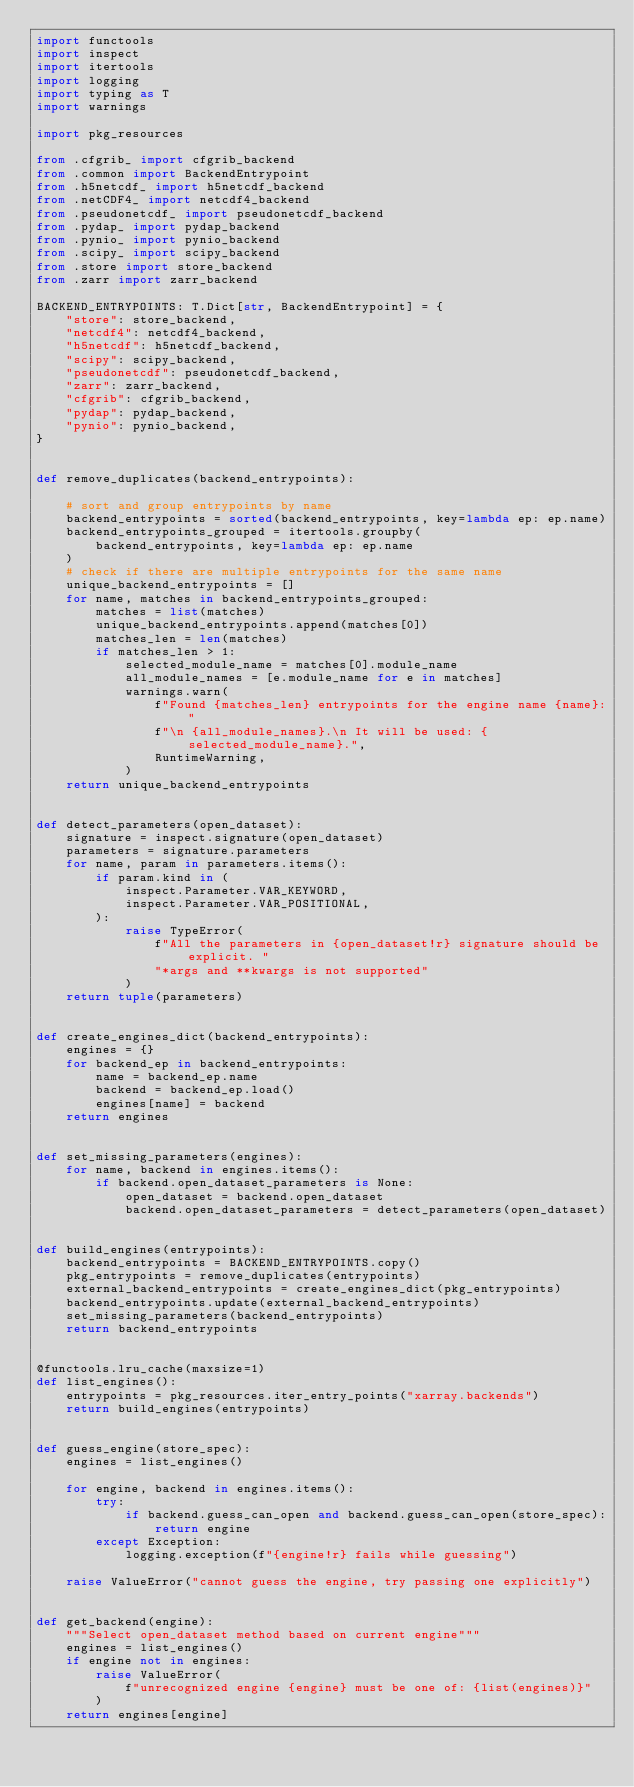Convert code to text. <code><loc_0><loc_0><loc_500><loc_500><_Python_>import functools
import inspect
import itertools
import logging
import typing as T
import warnings

import pkg_resources

from .cfgrib_ import cfgrib_backend
from .common import BackendEntrypoint
from .h5netcdf_ import h5netcdf_backend
from .netCDF4_ import netcdf4_backend
from .pseudonetcdf_ import pseudonetcdf_backend
from .pydap_ import pydap_backend
from .pynio_ import pynio_backend
from .scipy_ import scipy_backend
from .store import store_backend
from .zarr import zarr_backend

BACKEND_ENTRYPOINTS: T.Dict[str, BackendEntrypoint] = {
    "store": store_backend,
    "netcdf4": netcdf4_backend,
    "h5netcdf": h5netcdf_backend,
    "scipy": scipy_backend,
    "pseudonetcdf": pseudonetcdf_backend,
    "zarr": zarr_backend,
    "cfgrib": cfgrib_backend,
    "pydap": pydap_backend,
    "pynio": pynio_backend,
}


def remove_duplicates(backend_entrypoints):

    # sort and group entrypoints by name
    backend_entrypoints = sorted(backend_entrypoints, key=lambda ep: ep.name)
    backend_entrypoints_grouped = itertools.groupby(
        backend_entrypoints, key=lambda ep: ep.name
    )
    # check if there are multiple entrypoints for the same name
    unique_backend_entrypoints = []
    for name, matches in backend_entrypoints_grouped:
        matches = list(matches)
        unique_backend_entrypoints.append(matches[0])
        matches_len = len(matches)
        if matches_len > 1:
            selected_module_name = matches[0].module_name
            all_module_names = [e.module_name for e in matches]
            warnings.warn(
                f"Found {matches_len} entrypoints for the engine name {name}:"
                f"\n {all_module_names}.\n It will be used: {selected_module_name}.",
                RuntimeWarning,
            )
    return unique_backend_entrypoints


def detect_parameters(open_dataset):
    signature = inspect.signature(open_dataset)
    parameters = signature.parameters
    for name, param in parameters.items():
        if param.kind in (
            inspect.Parameter.VAR_KEYWORD,
            inspect.Parameter.VAR_POSITIONAL,
        ):
            raise TypeError(
                f"All the parameters in {open_dataset!r} signature should be explicit. "
                "*args and **kwargs is not supported"
            )
    return tuple(parameters)


def create_engines_dict(backend_entrypoints):
    engines = {}
    for backend_ep in backend_entrypoints:
        name = backend_ep.name
        backend = backend_ep.load()
        engines[name] = backend
    return engines


def set_missing_parameters(engines):
    for name, backend in engines.items():
        if backend.open_dataset_parameters is None:
            open_dataset = backend.open_dataset
            backend.open_dataset_parameters = detect_parameters(open_dataset)


def build_engines(entrypoints):
    backend_entrypoints = BACKEND_ENTRYPOINTS.copy()
    pkg_entrypoints = remove_duplicates(entrypoints)
    external_backend_entrypoints = create_engines_dict(pkg_entrypoints)
    backend_entrypoints.update(external_backend_entrypoints)
    set_missing_parameters(backend_entrypoints)
    return backend_entrypoints


@functools.lru_cache(maxsize=1)
def list_engines():
    entrypoints = pkg_resources.iter_entry_points("xarray.backends")
    return build_engines(entrypoints)


def guess_engine(store_spec):
    engines = list_engines()

    for engine, backend in engines.items():
        try:
            if backend.guess_can_open and backend.guess_can_open(store_spec):
                return engine
        except Exception:
            logging.exception(f"{engine!r} fails while guessing")

    raise ValueError("cannot guess the engine, try passing one explicitly")


def get_backend(engine):
    """Select open_dataset method based on current engine"""
    engines = list_engines()
    if engine not in engines:
        raise ValueError(
            f"unrecognized engine {engine} must be one of: {list(engines)}"
        )
    return engines[engine]
</code> 